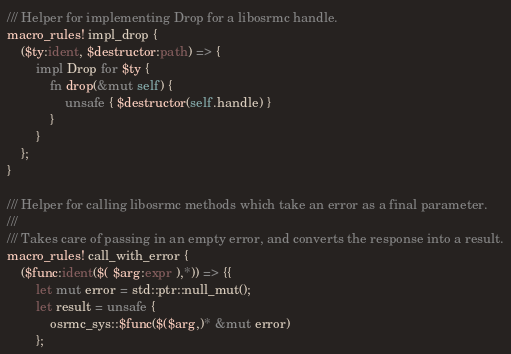Convert code to text. <code><loc_0><loc_0><loc_500><loc_500><_Rust_>/// Helper for implementing Drop for a libosrmc handle.
macro_rules! impl_drop {
    ($ty:ident, $destructor:path) => {
        impl Drop for $ty {
            fn drop(&mut self) {
                unsafe { $destructor(self.handle) }
            }
        }
    };
}

/// Helper for calling libosrmc methods which take an error as a final parameter.
///
/// Takes care of passing in an empty error, and converts the response into a result.
macro_rules! call_with_error {
    ($func:ident($( $arg:expr ),*)) => {{
        let mut error = std::ptr::null_mut();
        let result = unsafe {
            osrmc_sys::$func($($arg,)* &mut error)
        };</code> 